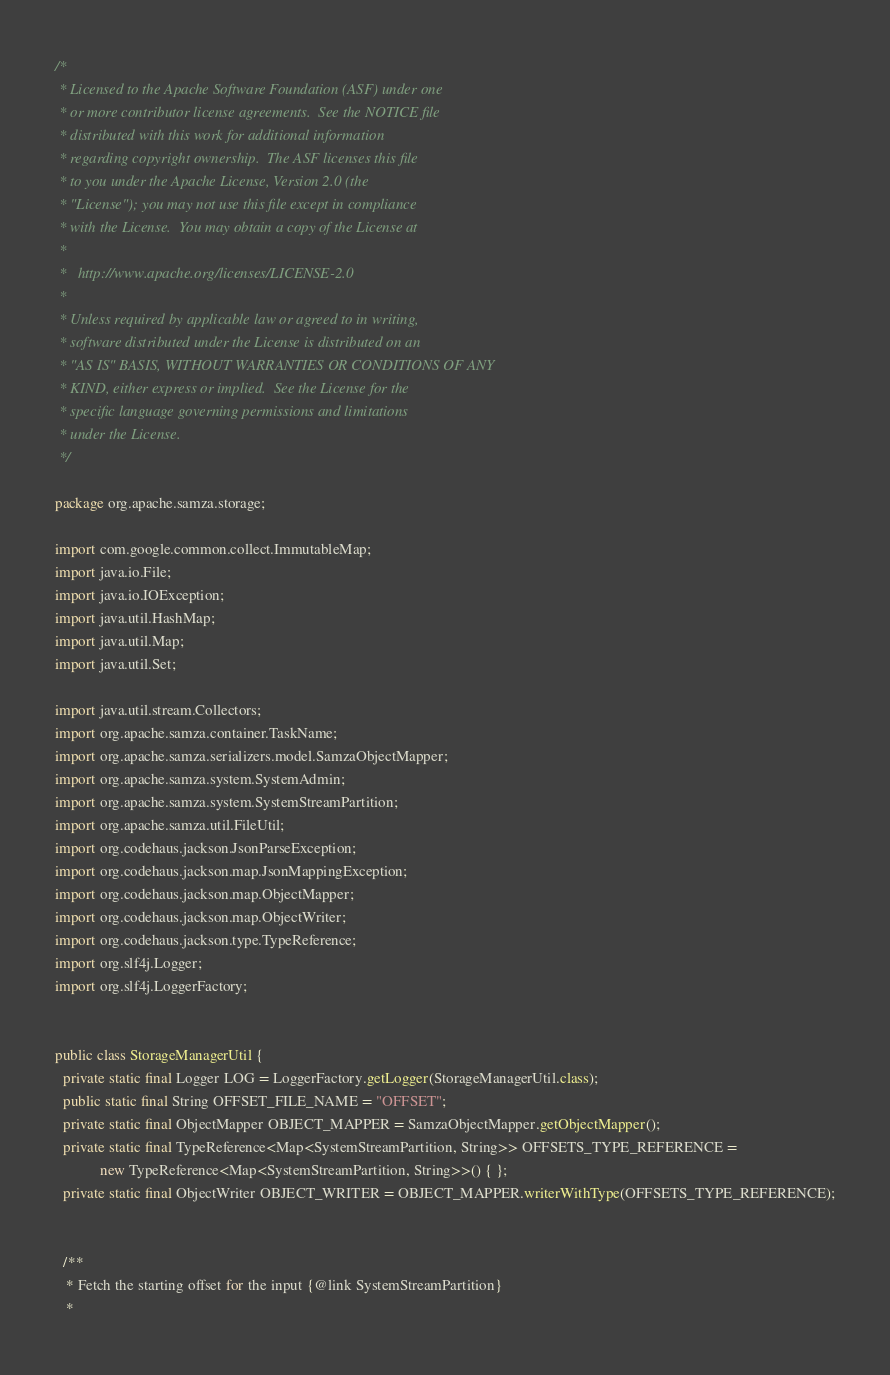<code> <loc_0><loc_0><loc_500><loc_500><_Java_>/*
 * Licensed to the Apache Software Foundation (ASF) under one
 * or more contributor license agreements.  See the NOTICE file
 * distributed with this work for additional information
 * regarding copyright ownership.  The ASF licenses this file
 * to you under the Apache License, Version 2.0 (the
 * "License"); you may not use this file except in compliance
 * with the License.  You may obtain a copy of the License at
 *
 *   http://www.apache.org/licenses/LICENSE-2.0
 *
 * Unless required by applicable law or agreed to in writing,
 * software distributed under the License is distributed on an
 * "AS IS" BASIS, WITHOUT WARRANTIES OR CONDITIONS OF ANY
 * KIND, either express or implied.  See the License for the
 * specific language governing permissions and limitations
 * under the License.
 */

package org.apache.samza.storage;

import com.google.common.collect.ImmutableMap;
import java.io.File;
import java.io.IOException;
import java.util.HashMap;
import java.util.Map;
import java.util.Set;

import java.util.stream.Collectors;
import org.apache.samza.container.TaskName;
import org.apache.samza.serializers.model.SamzaObjectMapper;
import org.apache.samza.system.SystemAdmin;
import org.apache.samza.system.SystemStreamPartition;
import org.apache.samza.util.FileUtil;
import org.codehaus.jackson.JsonParseException;
import org.codehaus.jackson.map.JsonMappingException;
import org.codehaus.jackson.map.ObjectMapper;
import org.codehaus.jackson.map.ObjectWriter;
import org.codehaus.jackson.type.TypeReference;
import org.slf4j.Logger;
import org.slf4j.LoggerFactory;


public class StorageManagerUtil {
  private static final Logger LOG = LoggerFactory.getLogger(StorageManagerUtil.class);
  public static final String OFFSET_FILE_NAME = "OFFSET";
  private static final ObjectMapper OBJECT_MAPPER = SamzaObjectMapper.getObjectMapper();
  private static final TypeReference<Map<SystemStreamPartition, String>> OFFSETS_TYPE_REFERENCE =
            new TypeReference<Map<SystemStreamPartition, String>>() { };
  private static final ObjectWriter OBJECT_WRITER = OBJECT_MAPPER.writerWithType(OFFSETS_TYPE_REFERENCE);


  /**
   * Fetch the starting offset for the input {@link SystemStreamPartition}
   *</code> 